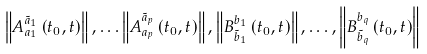<formula> <loc_0><loc_0><loc_500><loc_500>\left \| A _ { a _ { 1 } } ^ { \tilde { a } _ { 1 } } \left ( t _ { 0 } , t \right ) \right \| , \dots \left \| A _ { a _ { p } } ^ { \tilde { a } _ { p } } \left ( t _ { 0 } , t \right ) \right \| , \left \| B _ { \tilde { b } _ { 1 } } ^ { b _ { 1 } } \left ( t _ { 0 } , t \right ) \right \| , \dots , \left \| B _ { \tilde { b } _ { q } } ^ { b _ { q } } \left ( t _ { 0 } , t \right ) \right \|</formula> 